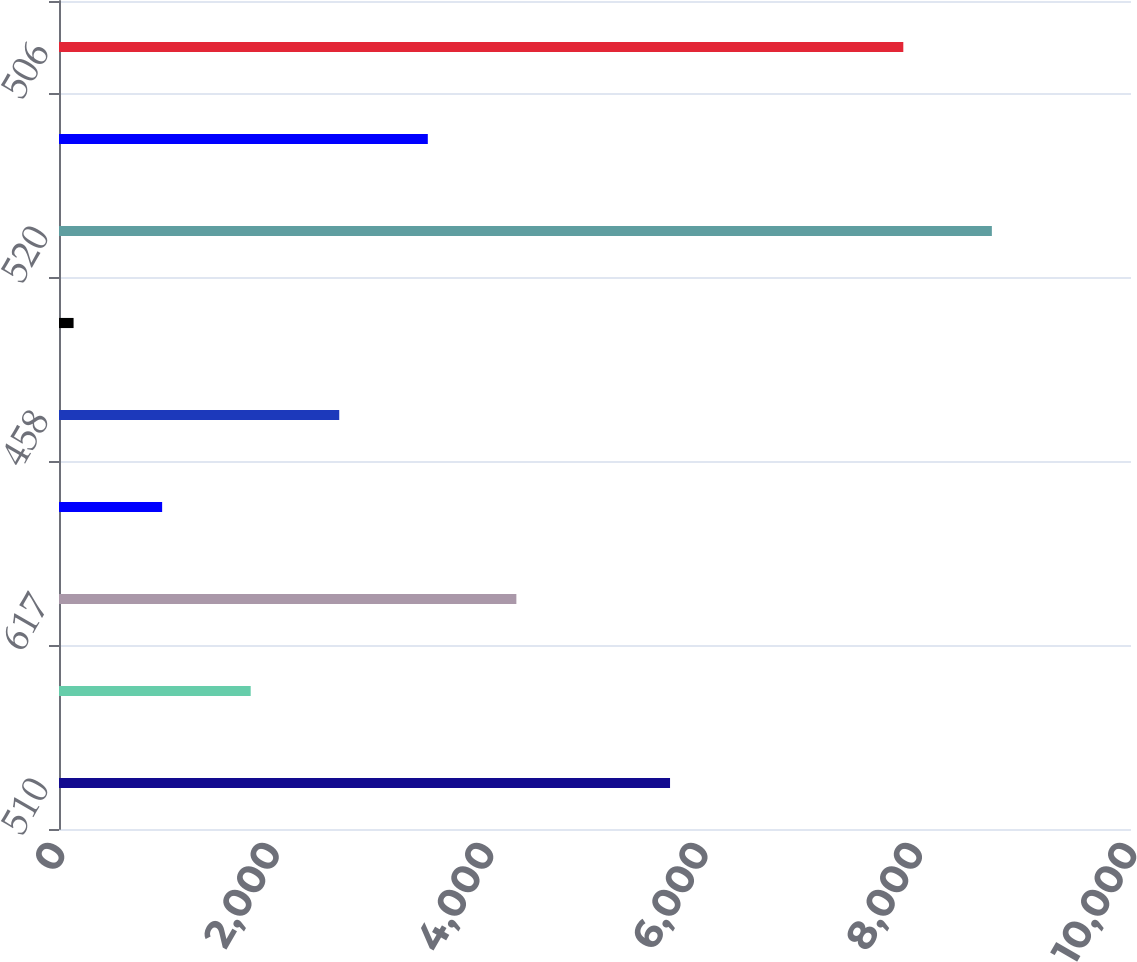Convert chart. <chart><loc_0><loc_0><loc_500><loc_500><bar_chart><fcel>510<fcel>495<fcel>617<fcel>523<fcel>458<fcel>480<fcel>520<fcel>(014)<fcel>506<nl><fcel>5700<fcel>1788.2<fcel>4266.5<fcel>962.1<fcel>2614.3<fcel>136<fcel>8702.1<fcel>3440.4<fcel>7876<nl></chart> 